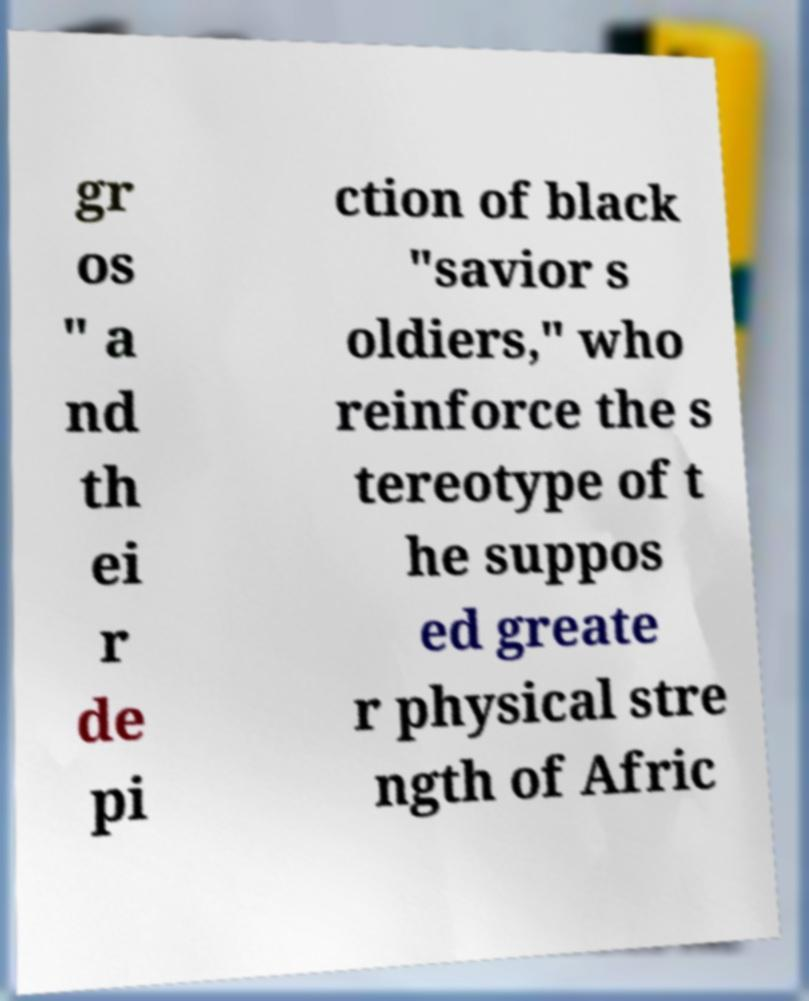Can you read and provide the text displayed in the image?This photo seems to have some interesting text. Can you extract and type it out for me? gr os " a nd th ei r de pi ction of black "savior s oldiers," who reinforce the s tereotype of t he suppos ed greate r physical stre ngth of Afric 